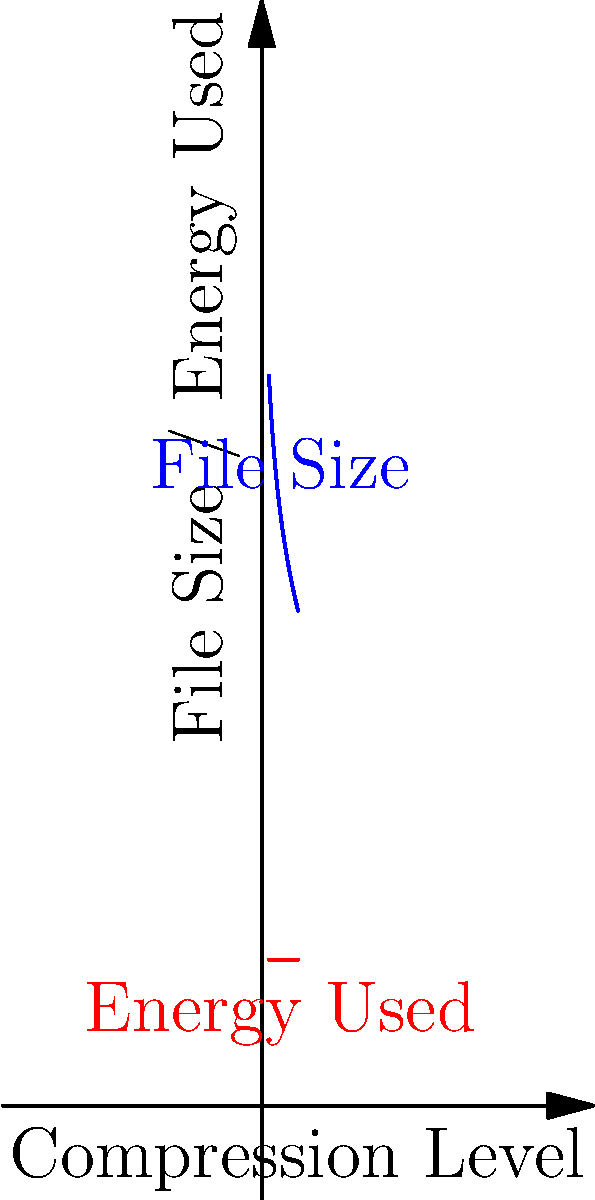In your proprietary file compression software, you notice that as the compression level increases, the file size decreases logarithmically, but the energy used by the algorithm remains constant. How does this relate to the conservation of energy principle, and what implications might this have for the efficiency of your compression algorithm? To understand this scenario in terms of energy conservation and efficiency, let's break it down step-by-step:

1. File size reduction:
   The graph shows that as compression level increases, file size decreases logarithmically, following the equation:
   $$\text{File Size} = 100 - 20\log(x)$$
   where $x$ is the compression level.

2. Energy usage:
   The energy used by the algorithm remains constant at 20 units, regardless of the compression level.

3. Conservation of energy:
   The principle of conservation of energy states that energy cannot be created or destroyed, only converted from one form to another. In this case:
   - The energy input (electricity used by the computer) is constant.
   - The energy output is divided between:
     a) Useful work (compressing the file)
     b) Waste energy (heat, etc.)

4. Efficiency analysis:
   - As compression level increases, more "work" is done (file size reduces), but energy input remains constant.
   - This implies that the algorithm becomes more efficient at higher compression levels, as it produces more output (smaller file size) for the same energy input.

5. Thermodynamic perspective:
   - The system is not closed, as it exchanges energy with its surroundings (computer hardware).
   - The constant energy usage suggests that the algorithm maintains a steady state, where energy input equals energy output.

6. Practical implications:
   - The algorithm's efficiency improves with higher compression levels, which is beneficial for reducing storage space.
   - However, the constant energy usage might not be optimal for all scenarios, especially when processing smaller files or when energy conservation is a priority.

7. Potential improvements:
   - An ideal algorithm would use less energy for lower compression levels, scaling its energy usage with the amount of work done.
   - This could involve optimizing the algorithm to use resources more dynamically based on the compression task at hand.
Answer: The constant energy usage with increasing compression efficiency suggests the algorithm becomes more thermodynamically efficient at higher compression levels, but may not be optimized for energy conservation across all usage scenarios. 